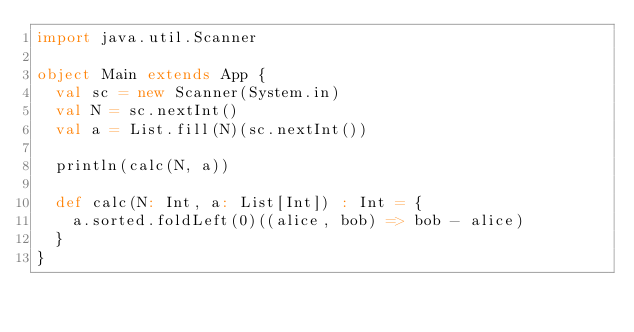Convert code to text. <code><loc_0><loc_0><loc_500><loc_500><_Scala_>import java.util.Scanner

object Main extends App {
  val sc = new Scanner(System.in)
  val N = sc.nextInt()
  val a = List.fill(N)(sc.nextInt())

  println(calc(N, a))

  def calc(N: Int, a: List[Int]) : Int = {
    a.sorted.foldLeft(0)((alice, bob) => bob - alice)
  }
}
</code> 